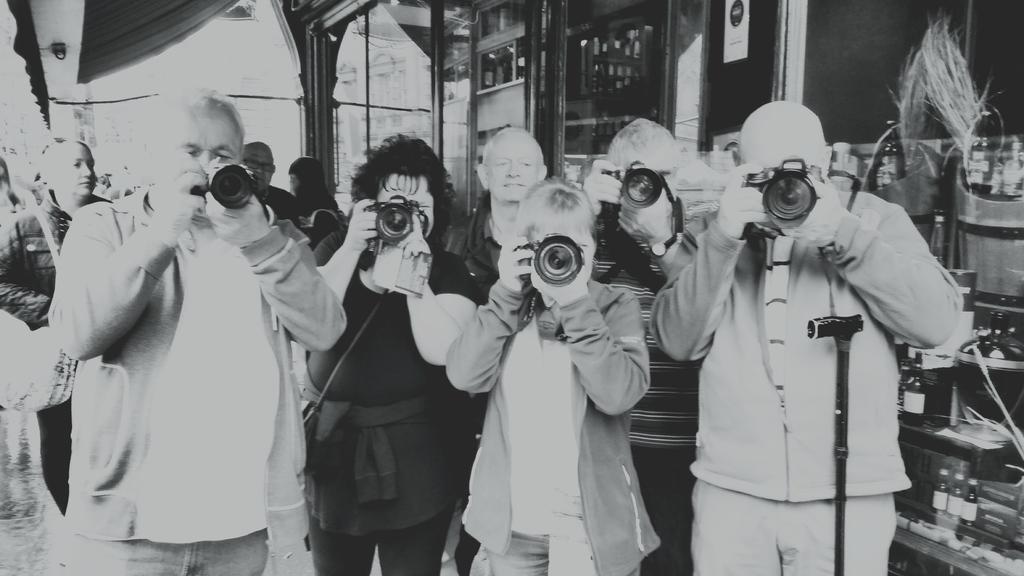Describe this image in one or two sentences. In this picture I can observe some people standing on the land. Some of them are holding cameras in their hands. There are men and women in this picture. This is a black and white image. 